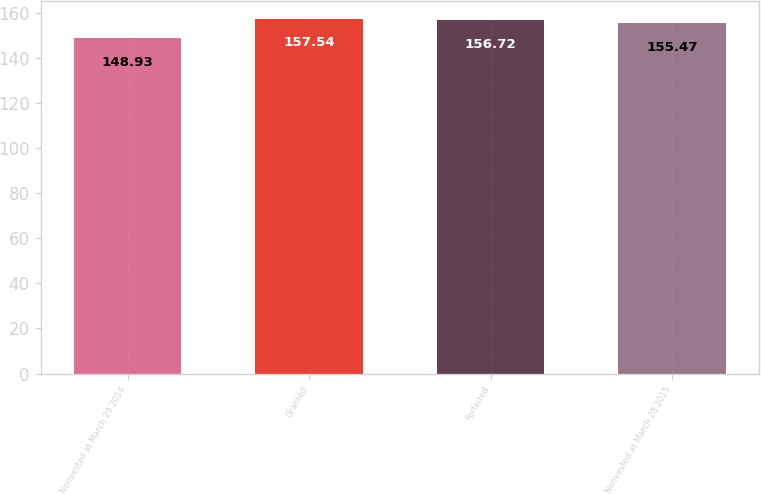<chart> <loc_0><loc_0><loc_500><loc_500><bar_chart><fcel>Nonvested at March 29 2014<fcel>Granted<fcel>Forfeited<fcel>Nonvested at March 28 2015<nl><fcel>148.93<fcel>157.54<fcel>156.72<fcel>155.47<nl></chart> 